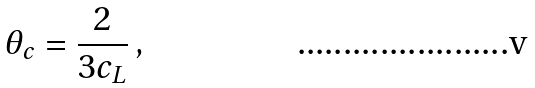<formula> <loc_0><loc_0><loc_500><loc_500>\theta _ { c } = \frac { 2 } { 3 c _ { L } } \, ,</formula> 